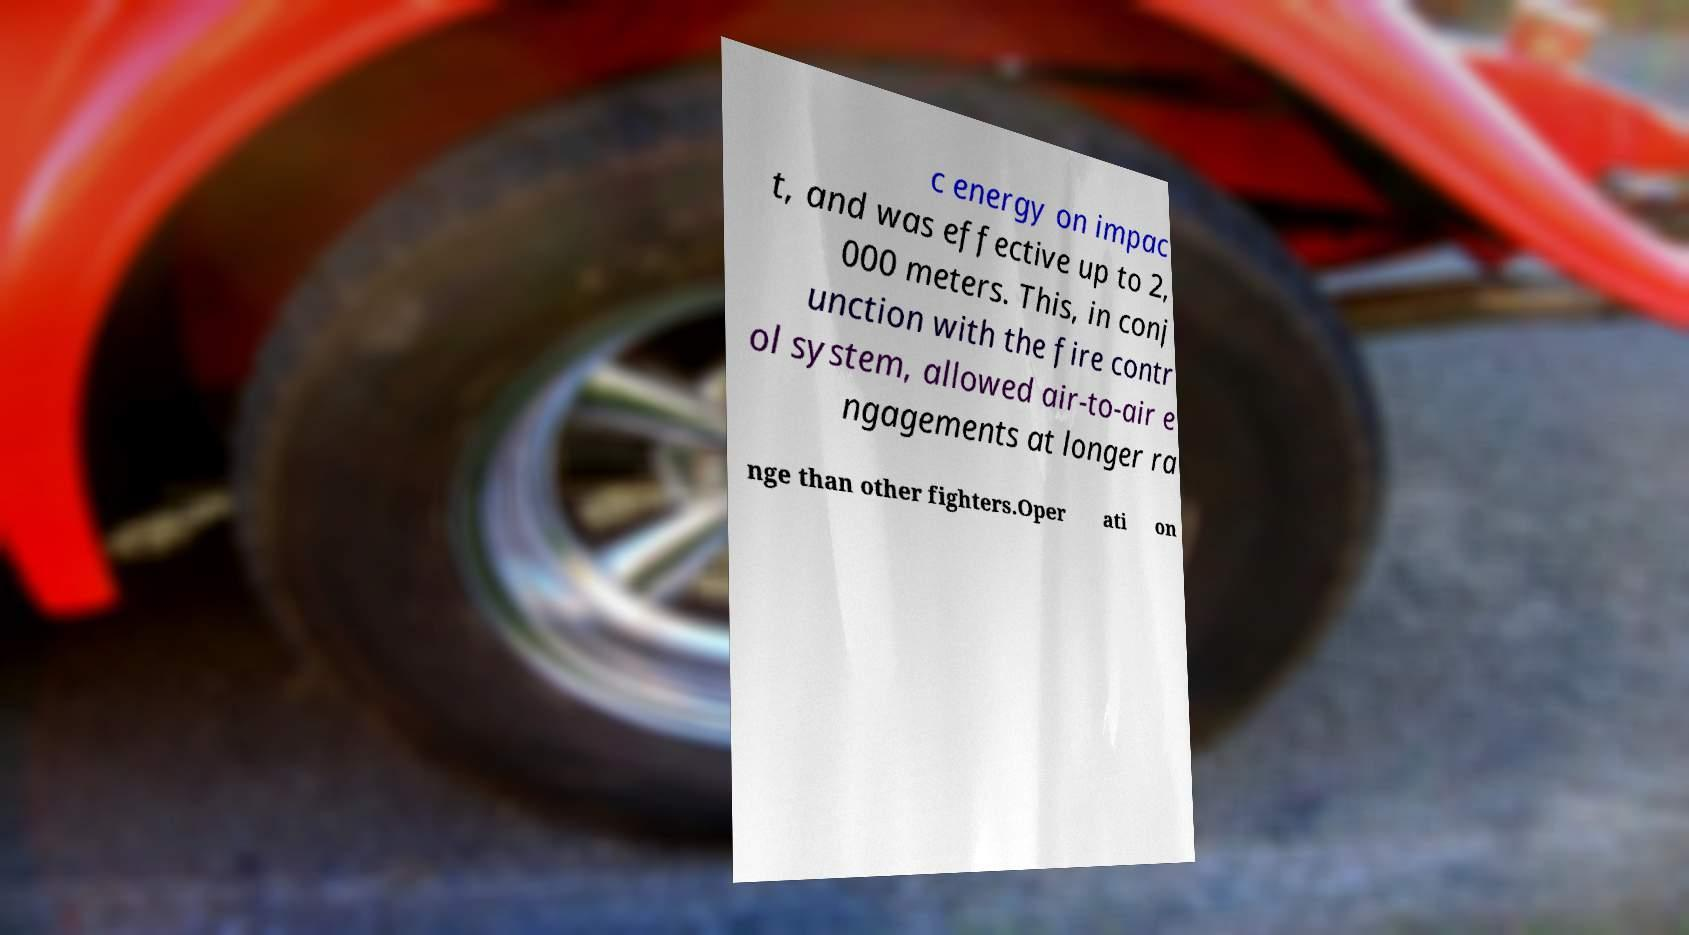I need the written content from this picture converted into text. Can you do that? c energy on impac t, and was effective up to 2, 000 meters. This, in conj unction with the fire contr ol system, allowed air-to-air e ngagements at longer ra nge than other fighters.Oper ati on 